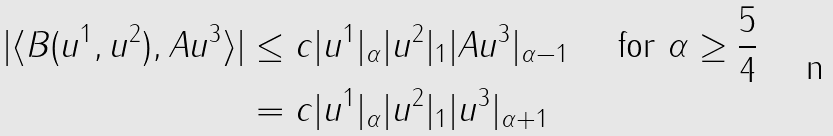<formula> <loc_0><loc_0><loc_500><loc_500>| \langle B ( u ^ { 1 } , u ^ { 2 } ) , A u ^ { 3 } \rangle | & \leq c | u ^ { 1 } | _ { \alpha } | u ^ { 2 } | _ { 1 } | A u ^ { 3 } | _ { \alpha - 1 } \quad \text { for } \alpha \geq \frac { 5 } { 4 } \\ & = c | u ^ { 1 } | _ { \alpha } | u ^ { 2 } | _ { 1 } | u ^ { 3 } | _ { \alpha + 1 }</formula> 